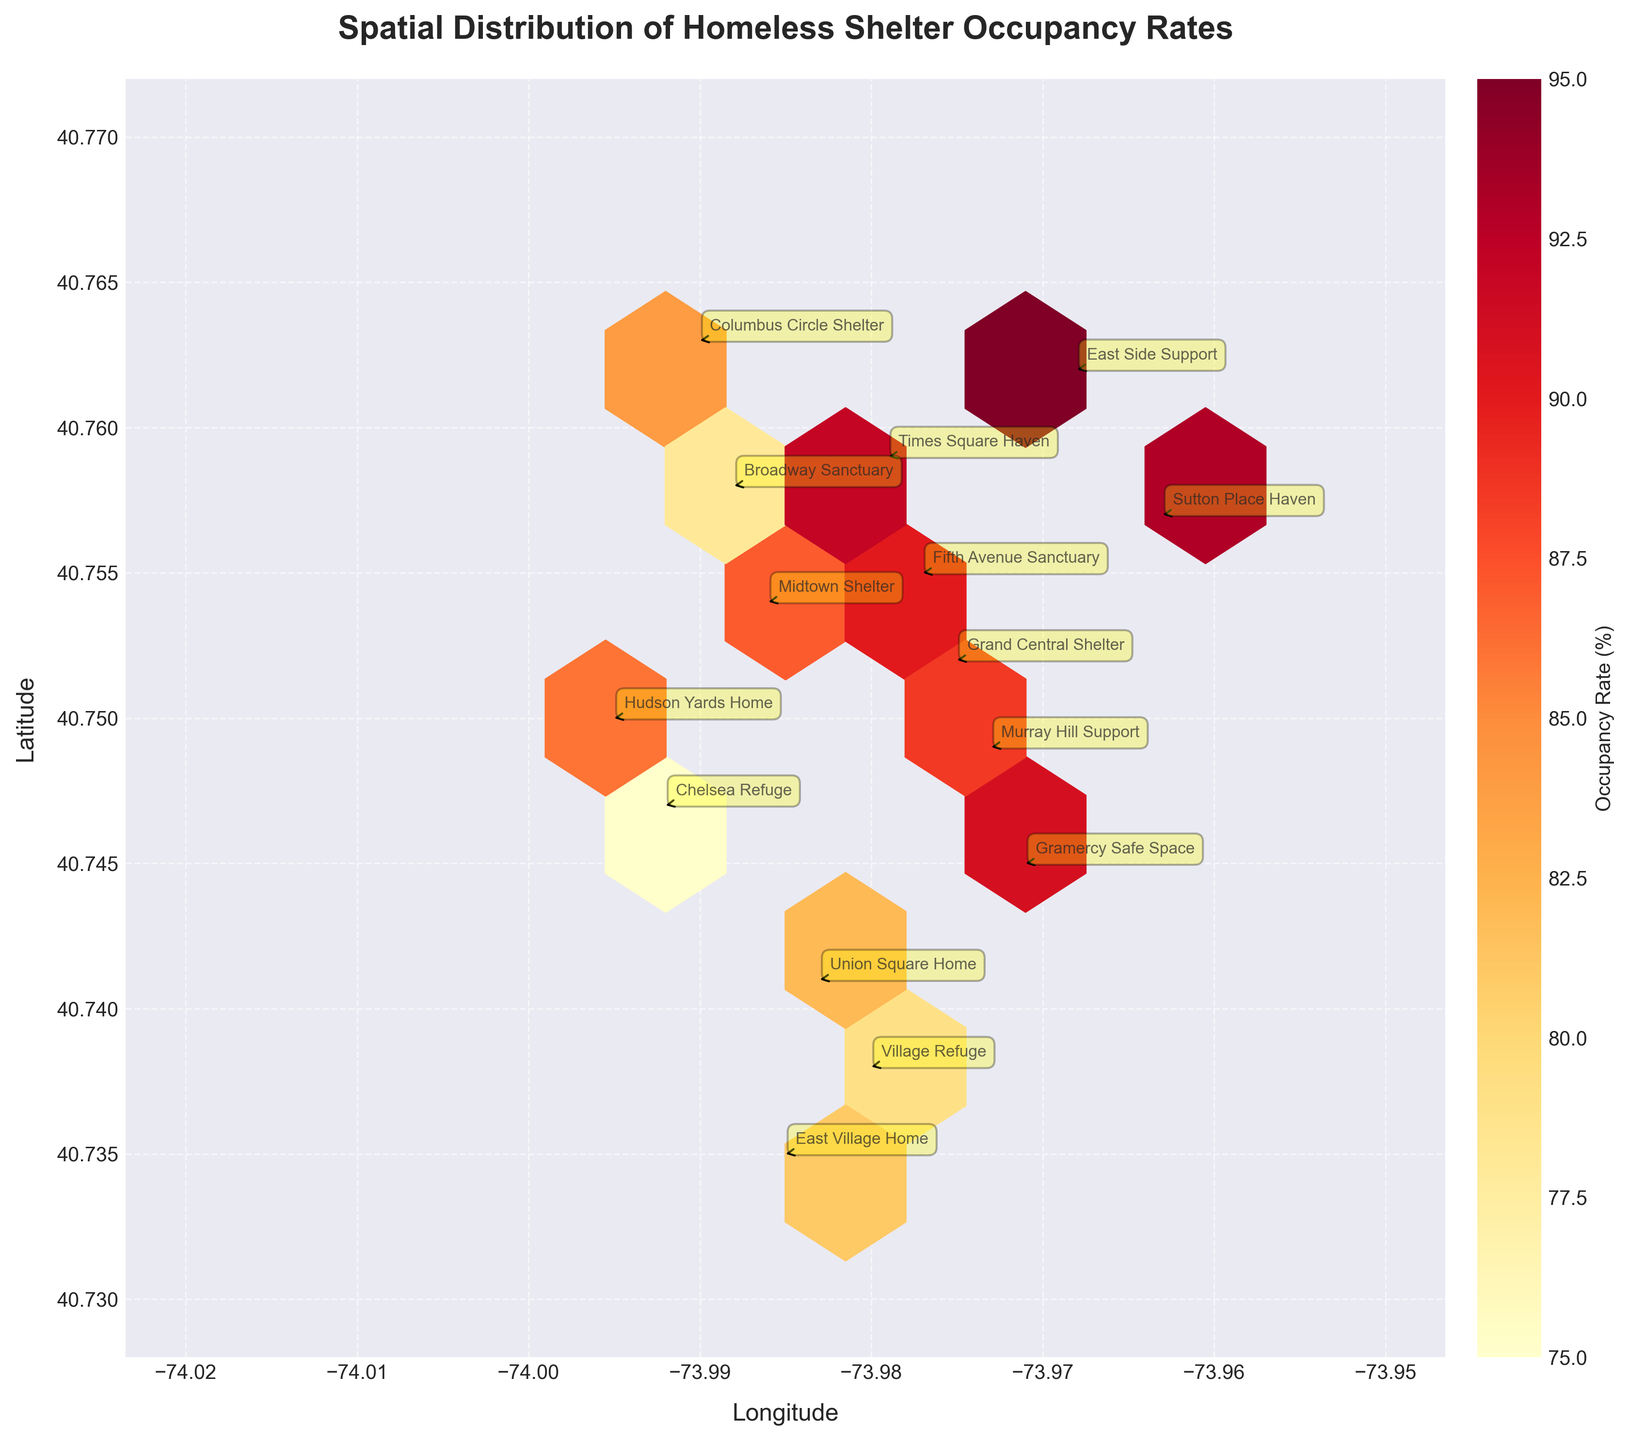How many shelters are annotated on the plot? The plot annotates each shelter with its name, and we can count the annotations. By counting each unique annotation on the figure, we find there are 15 shelters.
Answer: 15 What is the title of the plot? The title is clearly displayed at the top of the plot. It reads "Spatial Distribution of Homeless Shelter Occupancy Rates."
Answer: Spatial Distribution of Homeless Shelter Occupancy Rates Which shelter is located closest to the city center? By looking at the annotated shelter names and their distances to the center, the Grand Central Shelter is the closest with a distance of 0.5 units.
Answer: Grand Central Shelter Which shelter has the highest occupancy rate, and what is this rate? Checking each shelter's occupancy rate annotation, East Side Support has the highest rate of 95%.
Answer: East Side Support, 95% Is there any shelter without metro access that has an occupancy rate above 90%? By checking shelters annotated with "No" for metro access and comparing their occupancy rates, both Gramercy Safe Space and Sutton Place Haven meet the criteria with occupancy rates of 91% and 93%, respectively.
Answer: Yes What is the median occupancy rate of the shelters? First, list the occupancy rates in ascending order: 75, 78, 79, 81, 82, 84, 86, 87, 88, 89, 90, 91, 92, 93, 95. Since there are 15 data points, the median is the 8th value in the ordered list, which is 87%.
Answer: 87% What is the average distance of all shelters from the city center? Sum the distances and divide by the number of shelters: (1.2 + 0.8 + 2.1 + 1.5 + 2.3 + 0.5 + 1.1 + 2.7 + 1.9 + 3.2 + 2.4 + 1.3 + 1.7 + 3.5 + 0.9) / 15 = 1.8 units approximately.
Answer: 1.8 units Which shelter located furthest from the city center has metro access? Identifying shelters with the maximum distances first and checking metro access, the East Village Home is the furthest with metro access and is 3.5 units away from the center.
Answer: East Village Home Are there more shelters with occupancy rates above or below 85%? Counting shelters with occupancy rates above 85% (7 shelters: 87, 92, 95, 89, 91, 93, 90) and below 85% (8 shelters: 75, 78, 82, 78, 81, 84), there are more shelters below 85%.
Answer: below 85% How does the occupancy rate pattern change with distance from the metro hubs? By observing the color intensity of hexagons around metro-accessible areas and comparing with non-metro areas, generally, higher occupancy rates are clustered near metro-accessible locations, indicated by warmer colors.
Answer: Higher near metro 